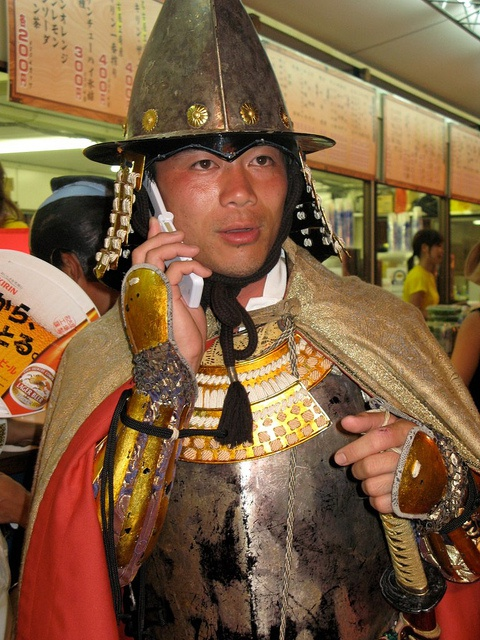Describe the objects in this image and their specific colors. I can see people in olive, black, gray, and maroon tones, people in olive, black, maroon, and gray tones, people in olive, black, and maroon tones, cell phone in olive, lightgray, gray, and black tones, and people in olive, maroon, brown, and black tones in this image. 